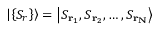<formula> <loc_0><loc_0><loc_500><loc_500>\left | \left \{ S _ { r } \right \} \right \rangle = \left | S _ { r _ { 1 } } , S _ { r _ { 2 } } , \dots , S _ { r _ { N } } \right \rangle</formula> 